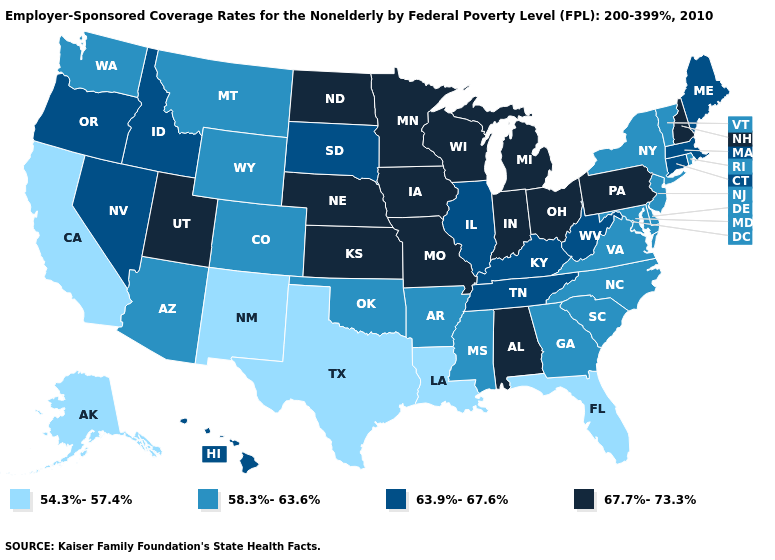What is the value of California?
Keep it brief. 54.3%-57.4%. Name the states that have a value in the range 63.9%-67.6%?
Keep it brief. Connecticut, Hawaii, Idaho, Illinois, Kentucky, Maine, Massachusetts, Nevada, Oregon, South Dakota, Tennessee, West Virginia. Does Ohio have the lowest value in the MidWest?
Short answer required. No. What is the value of North Dakota?
Concise answer only. 67.7%-73.3%. Does North Carolina have the same value as Arizona?
Write a very short answer. Yes. Which states hav the highest value in the South?
Write a very short answer. Alabama. Does Idaho have the highest value in the USA?
Concise answer only. No. What is the value of Tennessee?
Concise answer only. 63.9%-67.6%. What is the value of North Dakota?
Concise answer only. 67.7%-73.3%. What is the value of Montana?
Keep it brief. 58.3%-63.6%. Which states have the highest value in the USA?
Be succinct. Alabama, Indiana, Iowa, Kansas, Michigan, Minnesota, Missouri, Nebraska, New Hampshire, North Dakota, Ohio, Pennsylvania, Utah, Wisconsin. Which states have the lowest value in the USA?
Be succinct. Alaska, California, Florida, Louisiana, New Mexico, Texas. Which states hav the highest value in the MidWest?
Keep it brief. Indiana, Iowa, Kansas, Michigan, Minnesota, Missouri, Nebraska, North Dakota, Ohio, Wisconsin. What is the highest value in the USA?
Quick response, please. 67.7%-73.3%. What is the value of Texas?
Concise answer only. 54.3%-57.4%. 